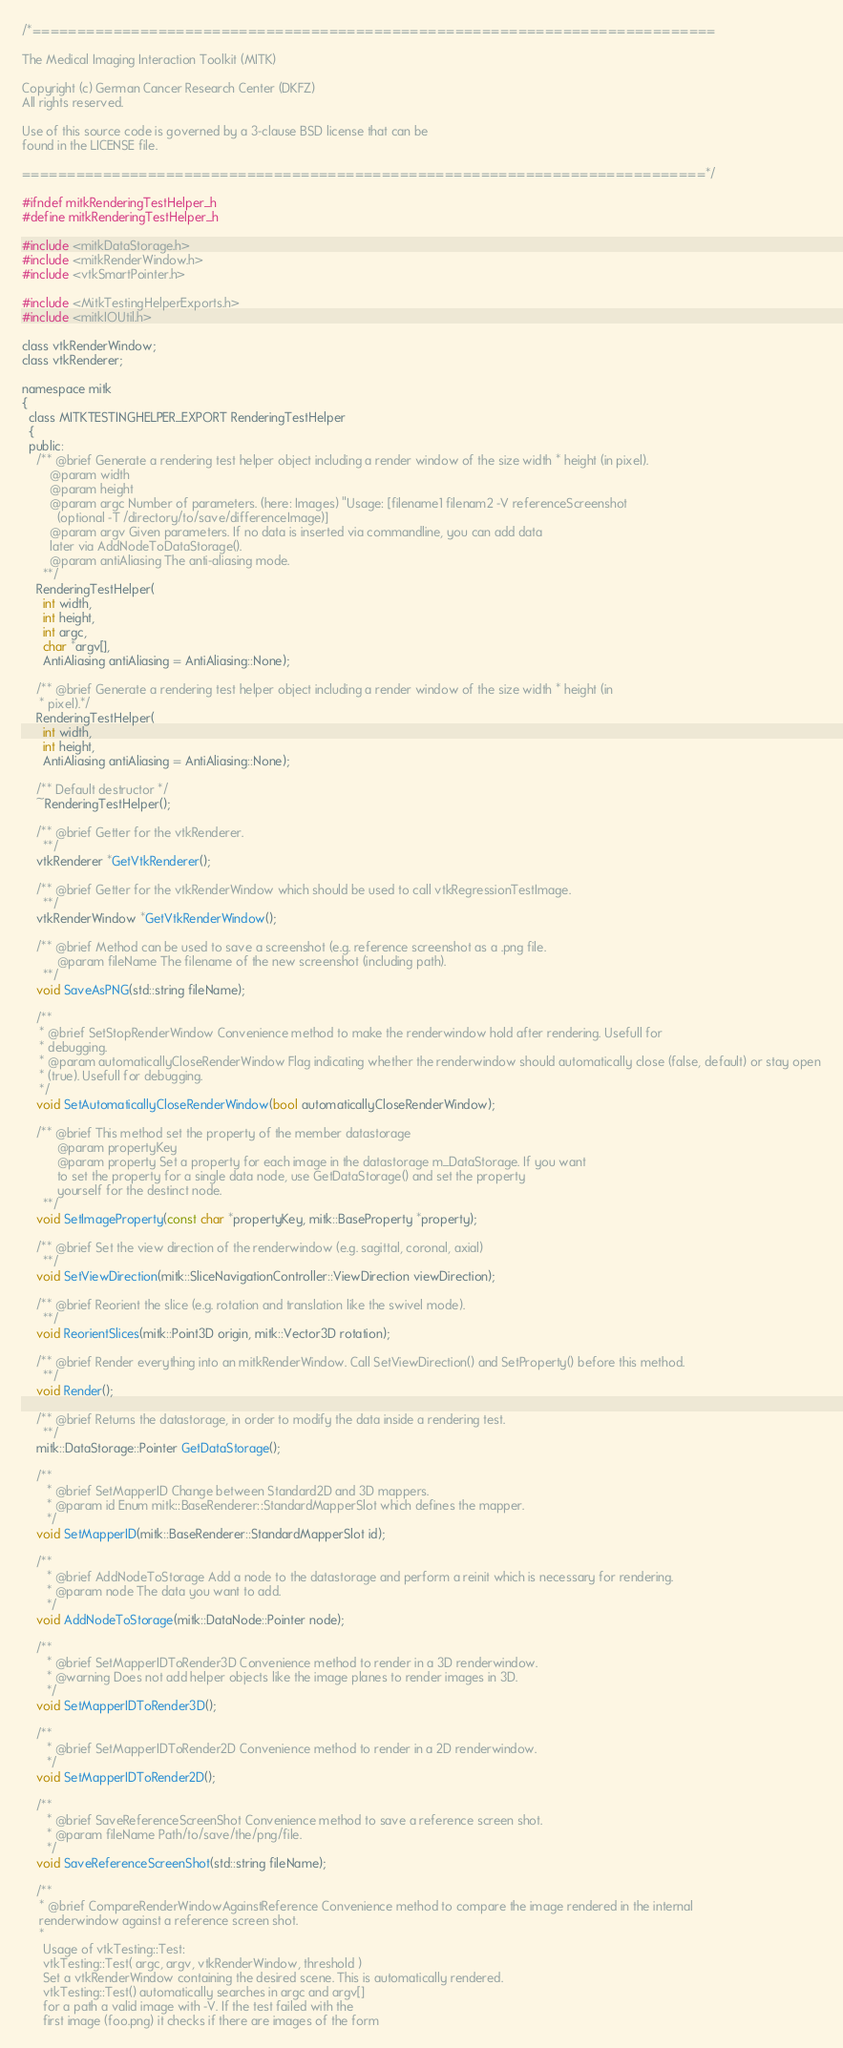<code> <loc_0><loc_0><loc_500><loc_500><_C_>/*============================================================================

The Medical Imaging Interaction Toolkit (MITK)

Copyright (c) German Cancer Research Center (DKFZ)
All rights reserved.

Use of this source code is governed by a 3-clause BSD license that can be
found in the LICENSE file.

============================================================================*/

#ifndef mitkRenderingTestHelper_h
#define mitkRenderingTestHelper_h

#include <mitkDataStorage.h>
#include <mitkRenderWindow.h>
#include <vtkSmartPointer.h>

#include <MitkTestingHelperExports.h>
#include <mitkIOUtil.h>

class vtkRenderWindow;
class vtkRenderer;

namespace mitk
{
  class MITKTESTINGHELPER_EXPORT RenderingTestHelper
  {
  public:
    /** @brief Generate a rendering test helper object including a render window of the size width * height (in pixel).
        @param width
        @param height
        @param argc Number of parameters. (here: Images) "Usage: [filename1 filenam2 -V referenceScreenshot
          (optional -T /directory/to/save/differenceImage)]
        @param argv Given parameters. If no data is inserted via commandline, you can add data
        later via AddNodeToDataStorage().
        @param antiAliasing The anti-aliasing mode.
      **/
    RenderingTestHelper(
      int width,
      int height,
      int argc,
      char *argv[],
      AntiAliasing antiAliasing = AntiAliasing::None);

    /** @brief Generate a rendering test helper object including a render window of the size width * height (in
     * pixel).*/
    RenderingTestHelper(
      int width,
      int height,
      AntiAliasing antiAliasing = AntiAliasing::None);

    /** Default destructor */
    ~RenderingTestHelper();

    /** @brief Getter for the vtkRenderer.
      **/
    vtkRenderer *GetVtkRenderer();

    /** @brief Getter for the vtkRenderWindow which should be used to call vtkRegressionTestImage.
      **/
    vtkRenderWindow *GetVtkRenderWindow();

    /** @brief Method can be used to save a screenshot (e.g. reference screenshot as a .png file.
          @param fileName The filename of the new screenshot (including path).
      **/
    void SaveAsPNG(std::string fileName);

    /**
     * @brief SetStopRenderWindow Convenience method to make the renderwindow hold after rendering. Usefull for
     * debugging.
     * @param automaticallyCloseRenderWindow Flag indicating whether the renderwindow should automatically close (false, default) or stay open
     * (true). Usefull for debugging.
     */
    void SetAutomaticallyCloseRenderWindow(bool automaticallyCloseRenderWindow);

    /** @brief This method set the property of the member datastorage
          @param propertyKey
          @param property Set a property for each image in the datastorage m_DataStorage. If you want
          to set the property for a single data node, use GetDataStorage() and set the property
          yourself for the destinct node.
      **/
    void SetImageProperty(const char *propertyKey, mitk::BaseProperty *property);

    /** @brief Set the view direction of the renderwindow (e.g. sagittal, coronal, axial)
      **/
    void SetViewDirection(mitk::SliceNavigationController::ViewDirection viewDirection);

    /** @brief Reorient the slice (e.g. rotation and translation like the swivel mode).
      **/
    void ReorientSlices(mitk::Point3D origin, mitk::Vector3D rotation);

    /** @brief Render everything into an mitkRenderWindow. Call SetViewDirection() and SetProperty() before this method.
      **/
    void Render();

    /** @brief Returns the datastorage, in order to modify the data inside a rendering test.
      **/
    mitk::DataStorage::Pointer GetDataStorage();

    /**
       * @brief SetMapperID Change between Standard2D and 3D mappers.
       * @param id Enum mitk::BaseRenderer::StandardMapperSlot which defines the mapper.
       */
    void SetMapperID(mitk::BaseRenderer::StandardMapperSlot id);

    /**
       * @brief AddNodeToStorage Add a node to the datastorage and perform a reinit which is necessary for rendering.
       * @param node The data you want to add.
       */
    void AddNodeToStorage(mitk::DataNode::Pointer node);

    /**
       * @brief SetMapperIDToRender3D Convenience method to render in a 3D renderwindow.
       * @warning Does not add helper objects like the image planes to render images in 3D.
       */
    void SetMapperIDToRender3D();

    /**
       * @brief SetMapperIDToRender2D Convenience method to render in a 2D renderwindow.
       */
    void SetMapperIDToRender2D();

    /**
       * @brief SaveReferenceScreenShot Convenience method to save a reference screen shot.
       * @param fileName Path/to/save/the/png/file.
       */
    void SaveReferenceScreenShot(std::string fileName);

    /**
     * @brief CompareRenderWindowAgainstReference Convenience method to compare the image rendered in the internal
     renderwindow against a reference screen shot.
     *
      Usage of vtkTesting::Test:
      vtkTesting::Test( argc, argv, vtkRenderWindow, threshold )
      Set a vtkRenderWindow containing the desired scene. This is automatically rendered.
      vtkTesting::Test() automatically searches in argc and argv[]
      for a path a valid image with -V. If the test failed with the
      first image (foo.png) it checks if there are images of the form</code> 